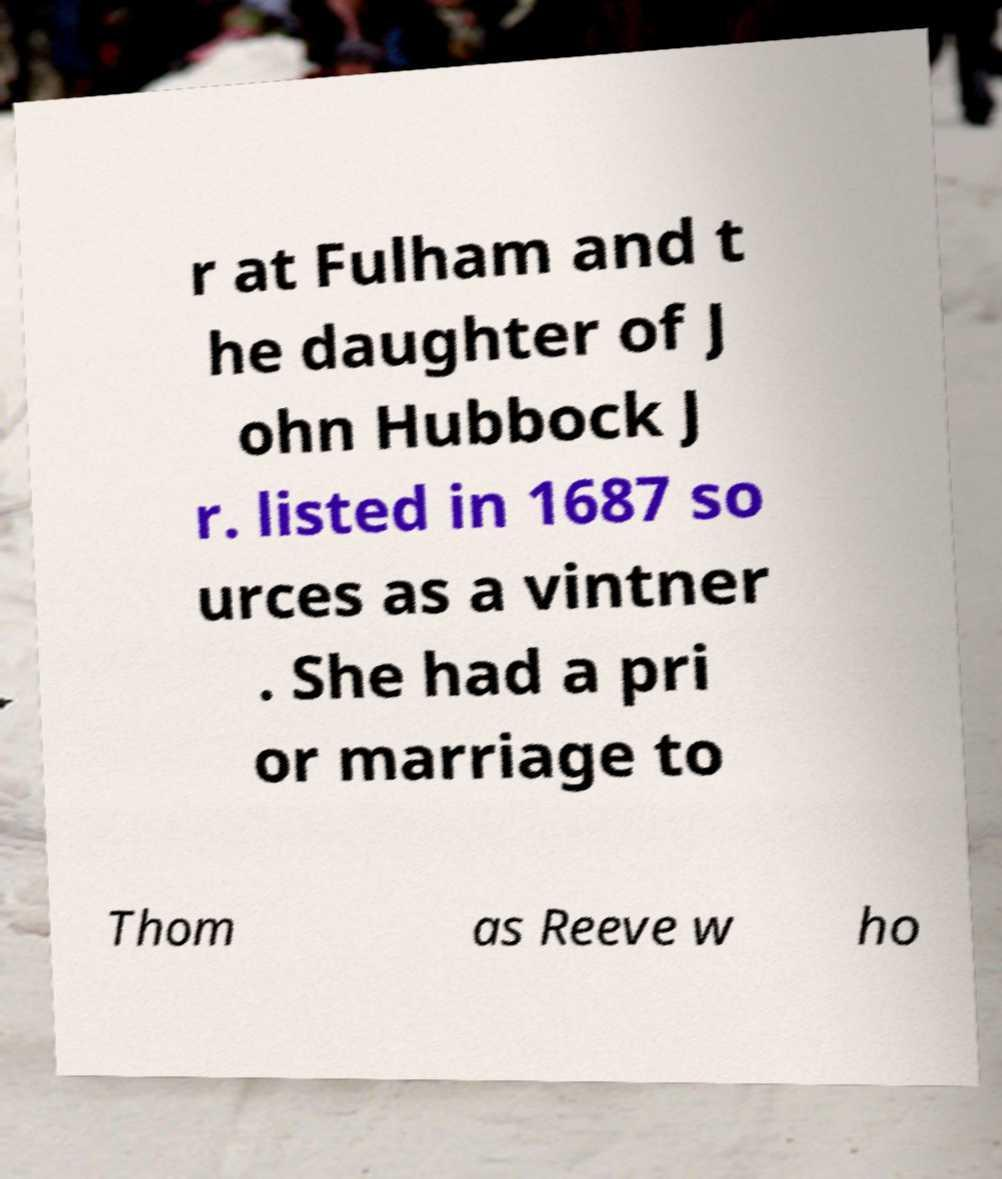There's text embedded in this image that I need extracted. Can you transcribe it verbatim? r at Fulham and t he daughter of J ohn Hubbock J r. listed in 1687 so urces as a vintner . She had a pri or marriage to Thom as Reeve w ho 